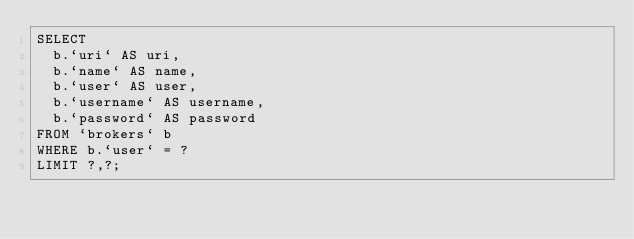Convert code to text. <code><loc_0><loc_0><loc_500><loc_500><_SQL_>SELECT 
  b.`uri` AS uri,
  b.`name` AS name,
  b.`user` AS user,
  b.`username` AS username,  
  b.`password` AS password 
FROM `brokers` b
WHERE b.`user` = ?
LIMIT ?,?;</code> 